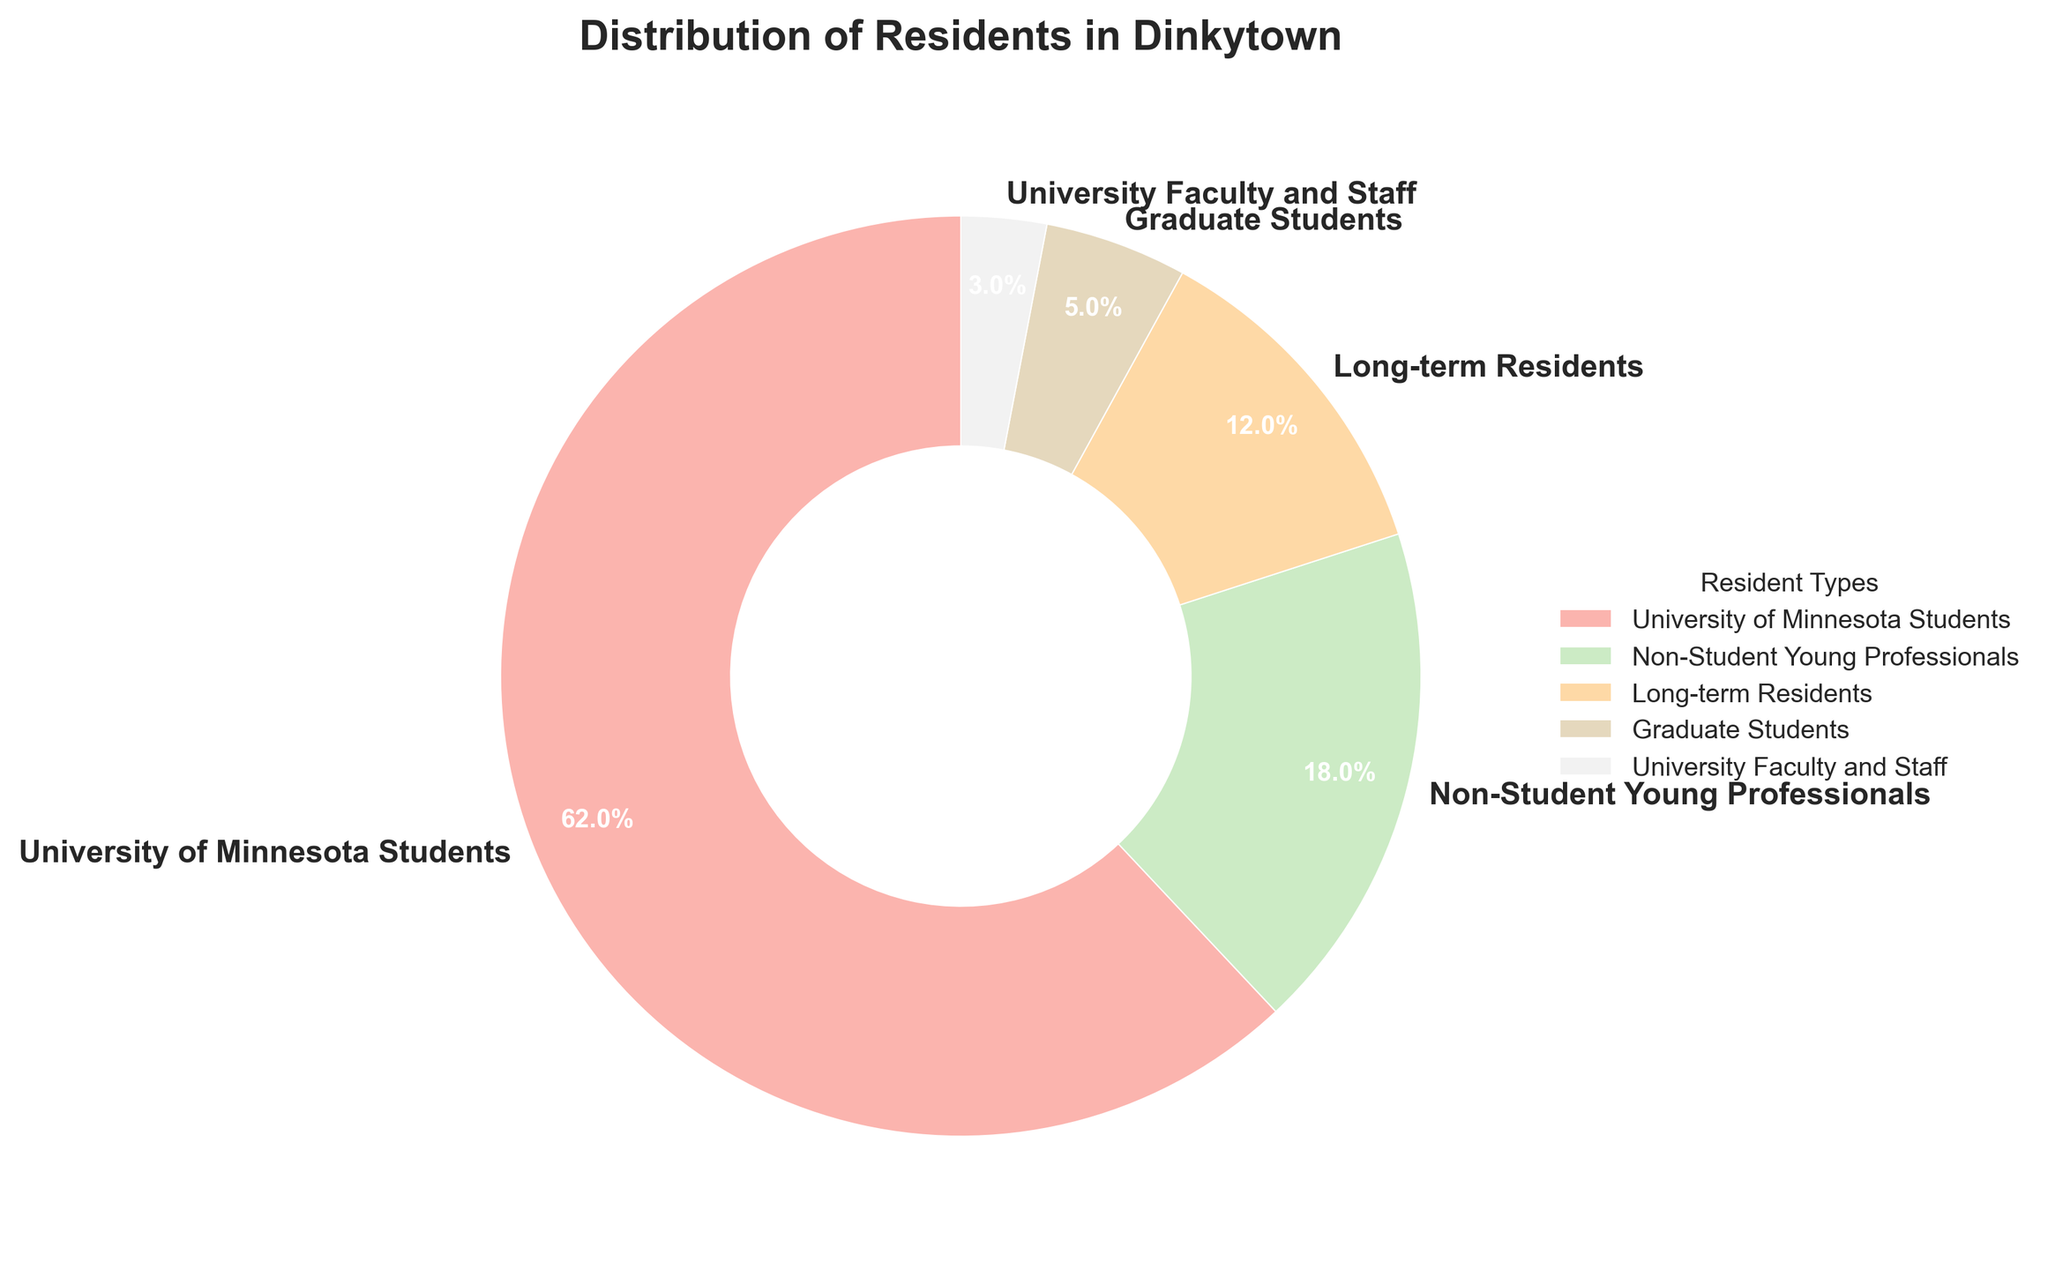What percentage of Dinkytown residents are students (both undergraduate and graduate)? Add the percentages of University of Minnesota Students (62%) and Graduate Students (5%) to get the total percentage of students. 62% + 5% = 67%
Answer: 67% Which resident type has the second-highest percentage in Dinkytown? From the pie chart, the resident type with the highest percentage is University of Minnesota Students (62%). The second-highest percentage is Non-Student Young Professionals at 18%.
Answer: Non-Student Young Professionals What is the combined percentage of long-term residents and University Faculty and Staff? Add the percentages of Long-term Residents (12%) and University Faculty and Staff (3%). 12% + 3% = 15%
Answer: 15% Which resident type occupies the smallest portion of the pie chart? The resident type with the smallest percentage value is University Faculty and Staff at 3%.
Answer: University Faculty and Staff By how much does the percentage of University of Minnesota Students exceed the percentage of Non-Student Young Professionals? Subtract the percentage of Non-Student Young Professionals (18%) from University of Minnesota Students (62%). 62% - 18% = 44%
Answer: 44% What percentage of residents are either young professionals or long-term residents? Add the percentages of Non-Student Young Professionals (18%) and Long-term Residents (12%). 18% + 12% = 30%
Answer: 30% How does the percentage of Graduate Students compare to the percentage of University Faculty and Staff? Graduate Students make up 5% of the residents, while University Faculty and Staff make up 3%. 5% is greater than 3% by 2%.
Answer: 2% If the pie chart is divided by students and non-students, what percentage would be non-students? Sum the percentages of Non-Student Young Professionals (18%), Long-term Residents (12%), and University Faculty and Staff (3%). 18% + 12% + 3% = 33%.
Answer: 33% What is the ratio of University of Minnesota Students to Graduate Students? The percentage of University of Minnesota Students is 62% and Graduate Students is 5%. The ratio is 62/5, which simplifies to 62:5 or approximately 12.4:1.
Answer: 12.4:1 